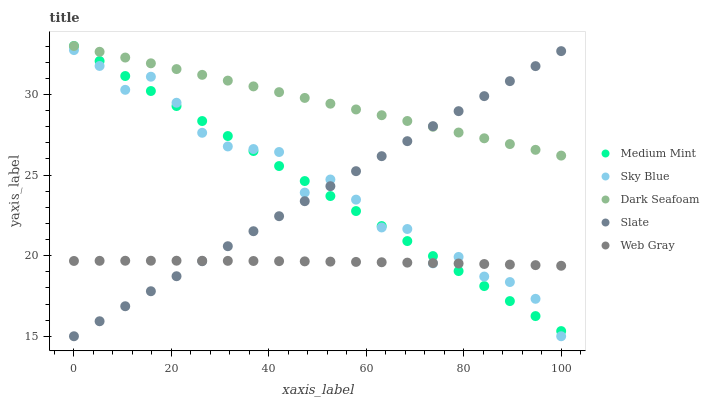Does Web Gray have the minimum area under the curve?
Answer yes or no. Yes. Does Dark Seafoam have the maximum area under the curve?
Answer yes or no. Yes. Does Sky Blue have the minimum area under the curve?
Answer yes or no. No. Does Sky Blue have the maximum area under the curve?
Answer yes or no. No. Is Medium Mint the smoothest?
Answer yes or no. Yes. Is Sky Blue the roughest?
Answer yes or no. Yes. Is Dark Seafoam the smoothest?
Answer yes or no. No. Is Dark Seafoam the roughest?
Answer yes or no. No. Does Sky Blue have the lowest value?
Answer yes or no. Yes. Does Dark Seafoam have the lowest value?
Answer yes or no. No. Does Dark Seafoam have the highest value?
Answer yes or no. Yes. Does Sky Blue have the highest value?
Answer yes or no. No. Is Web Gray less than Dark Seafoam?
Answer yes or no. Yes. Is Dark Seafoam greater than Sky Blue?
Answer yes or no. Yes. Does Medium Mint intersect Sky Blue?
Answer yes or no. Yes. Is Medium Mint less than Sky Blue?
Answer yes or no. No. Is Medium Mint greater than Sky Blue?
Answer yes or no. No. Does Web Gray intersect Dark Seafoam?
Answer yes or no. No. 